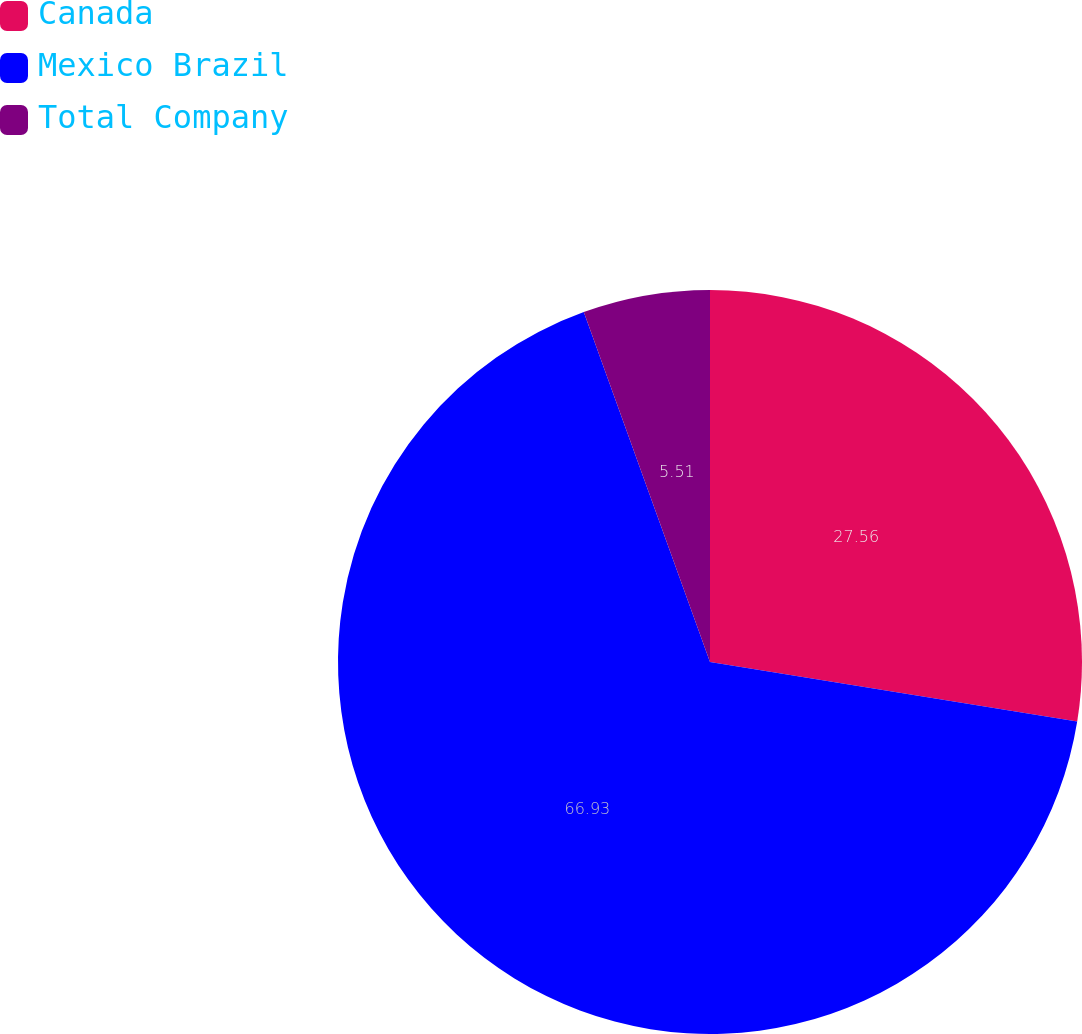Convert chart. <chart><loc_0><loc_0><loc_500><loc_500><pie_chart><fcel>Canada<fcel>Mexico Brazil<fcel>Total Company<nl><fcel>27.56%<fcel>66.93%<fcel>5.51%<nl></chart> 